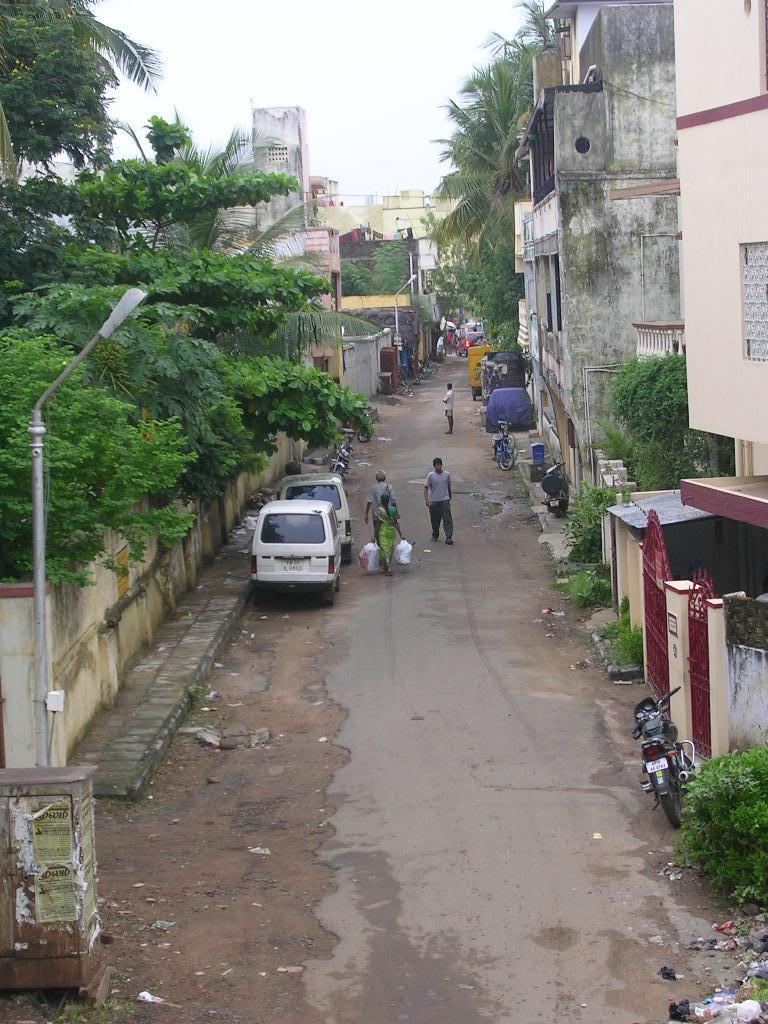In one or two sentences, can you explain what this image depicts? In this image I can see a road in the centre and on it I can see few people and few vehicles. On the both side of the road I can see number of trees and number of buildings. On the left side of this image I can see a pole and a street light. I can also see garbage on the bottom right corner of this image. 